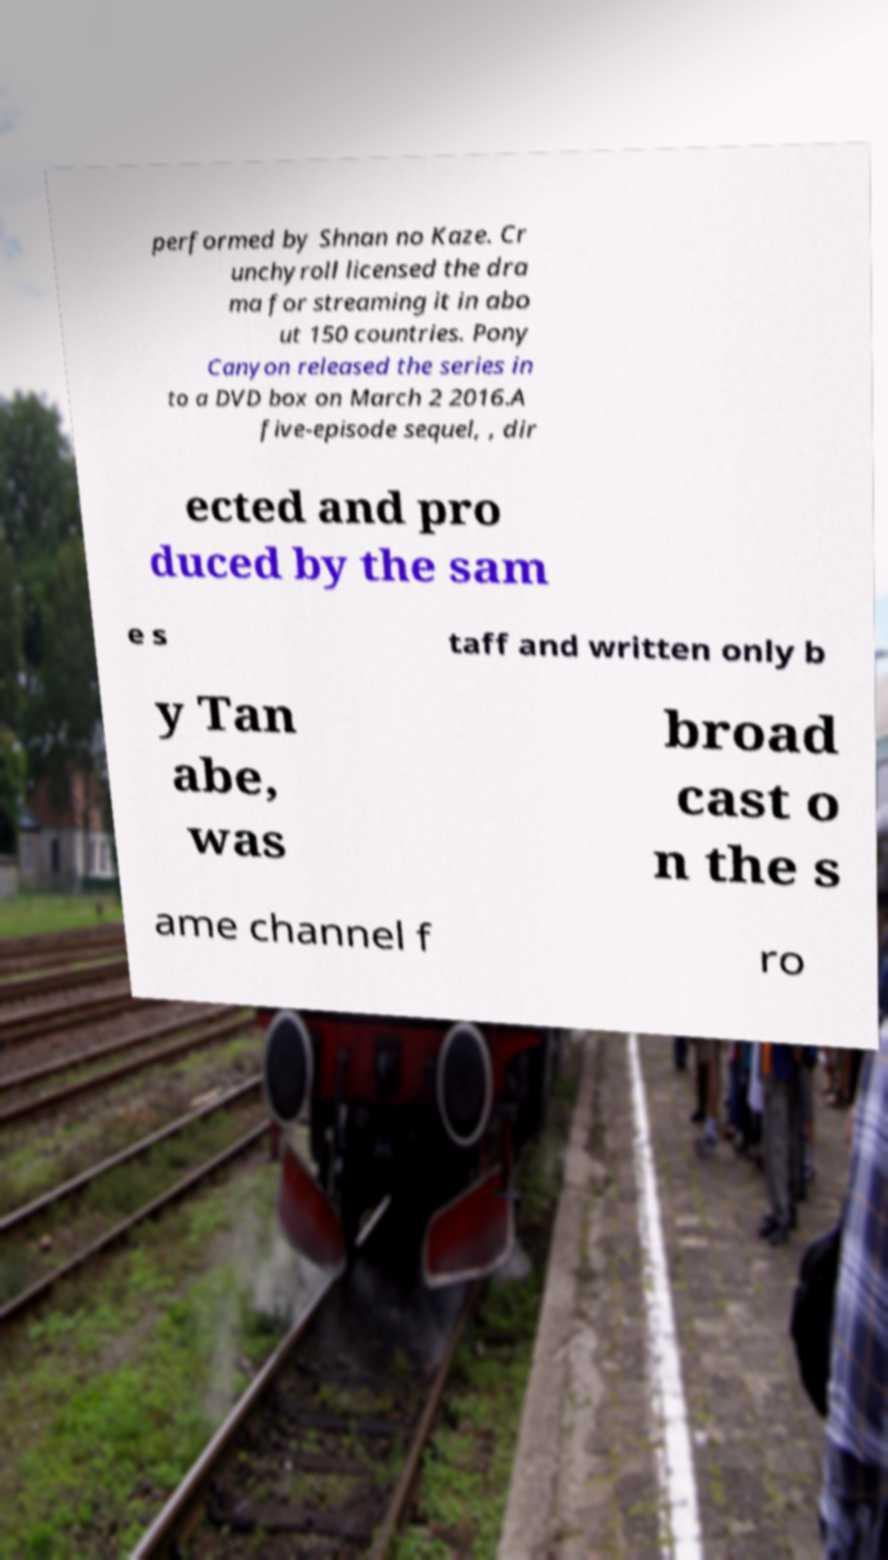I need the written content from this picture converted into text. Can you do that? performed by Shnan no Kaze. Cr unchyroll licensed the dra ma for streaming it in abo ut 150 countries. Pony Canyon released the series in to a DVD box on March 2 2016.A five-episode sequel, , dir ected and pro duced by the sam e s taff and written only b y Tan abe, was broad cast o n the s ame channel f ro 